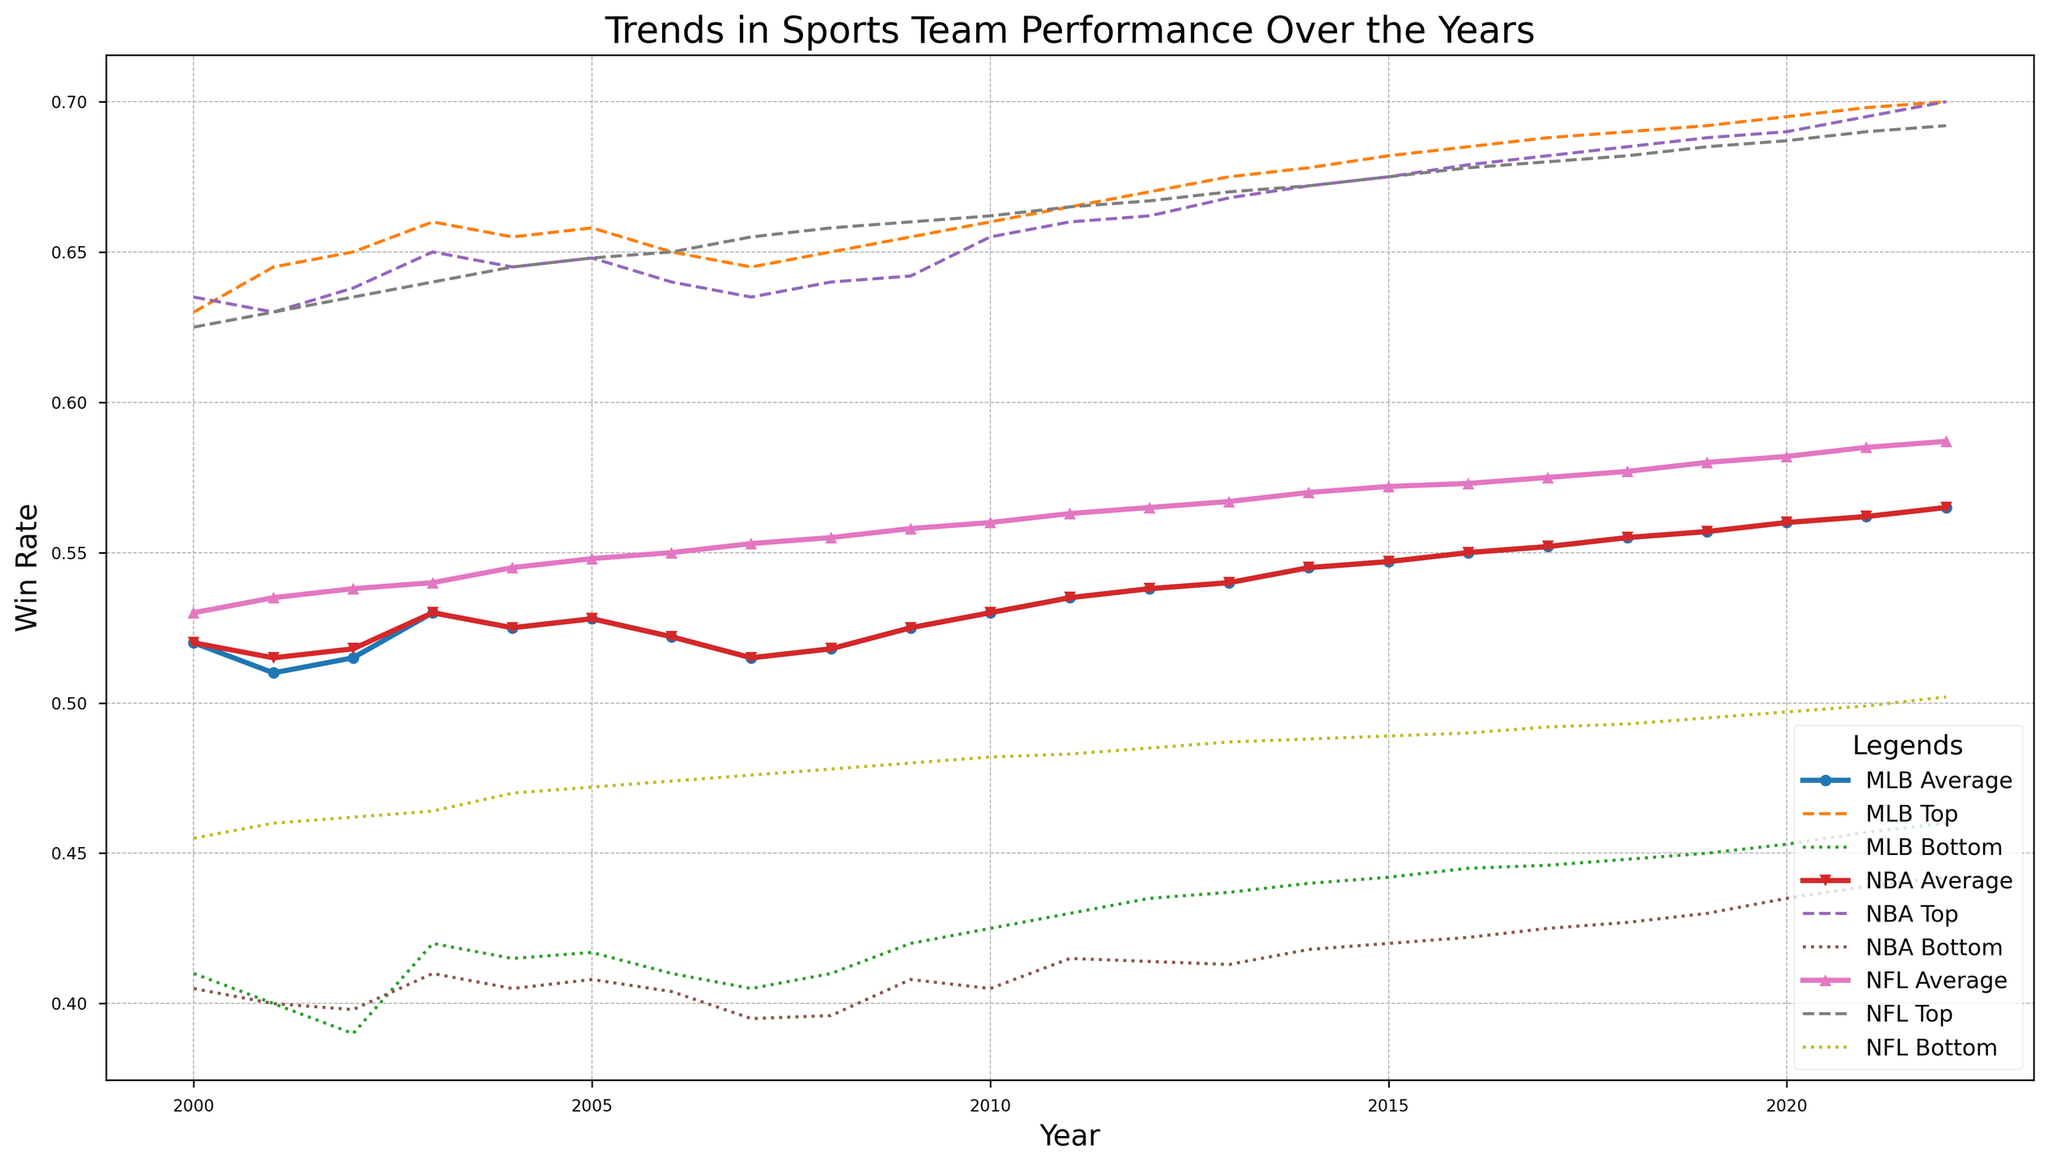Which league's average win rate increased the most from 2000 to 2022? To determine which league's average win rate increased the most, look at the difference between the 2022 and 2000 values for each league. For MLB, the increase is 0.565 - 0.520 = 0.045; for NBA, the increase is 0.565 - 0.520 = 0.045; for NFL, the increase is 0.587 - 0.530 = 0.057. Therefore, the NFL's average win rate increased the most.
Answer: NFL Which league had the highest top team win rate in 2022? To find the highest top team win rate in 2022, compare the top win rates of each league. The top rates are: MLB (0.700), NBA (0.700), and NFL (0.692). MLB and NBA are tied with the highest top team win rate.
Answer: MLB and NBA During which year did the MLB have its lowest bottom team win rate? To find the lowest bottom team win rate for MLB, scan the bottom team win rates for all years. The lowest value is 0.390 in 2002.
Answer: 2002 How does the increase in average win rate for the NFL from 2000 to 2022 compare to the NBA? The increase for the NFL is calculated as 0.587 - 0.530 = 0.057. For the NBA, it's 0.565 - 0.520 = 0.045. Comparing the two, the NFL's increase of 0.057 is larger than the NBA's increase of 0.045.
Answer: NFL's increase is larger In which year did the trend lines of the top team win rates for MLB and NFL first intersect, if any? To find the intersection year, check the top team win rates for both MLB and NFL for each year and look for the point they first match. Both win rates are equal at 0.640 in 2003.
Answer: 2003 Which league has the sharpest overall increase in bottom team win rate from 2000 to 2022? Calculate the increase in bottom team win rates from 2000 to 2022: MLB (0.460 - 0.410 = 0.050), NBA (0.442 - 0.405 = 0.037), NFL (0.502 - 0.455 = 0.047). MLB has the sharpest increase.
Answer: MLB What is the range of bottom team win rates for the NFL in 2022? To find the range, subtract the bottom team win rate from the top team win rate for the NFL in 2022: 0.692 - 0.502 = 0.190.
Answer: 0.190 In what year did the NBA top team win rate first exceed 0.670? Scan the NBA's top team win rates until you find the year it first goes above 0.670. This happens in 2013 with a win rate of 0.668.
Answer: 2013 By how much did the average win rate of the MLB in 2015 exceed that of 2010? Subtract the average win rate of 2010 from 2015 for the MLB: 0.547 - 0.530 = 0.017.
Answer: 0.017 